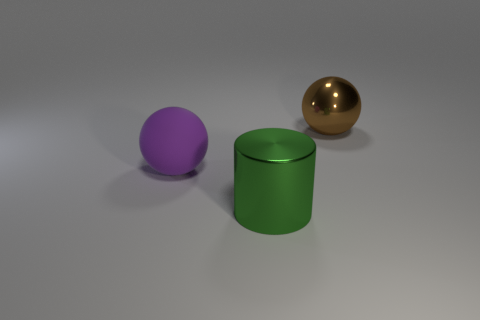What number of other things are the same shape as the purple thing?
Provide a succinct answer. 1. Does the brown metallic thing have the same shape as the big metal thing that is in front of the large shiny sphere?
Provide a short and direct response. No. There is a large brown metallic sphere; how many large metallic spheres are on the left side of it?
Make the answer very short. 0. Is there anything else that has the same material as the brown sphere?
Give a very brief answer. Yes. Does the big object that is on the left side of the green cylinder have the same shape as the green thing?
Provide a succinct answer. No. The shiny object that is left of the shiny sphere is what color?
Give a very brief answer. Green. What shape is the green thing that is the same material as the brown object?
Make the answer very short. Cylinder. Is there any other thing that is the same color as the cylinder?
Give a very brief answer. No. Is the number of large rubber spheres right of the purple rubber object greater than the number of big purple matte spheres that are behind the brown metal object?
Provide a short and direct response. No. What number of yellow shiny spheres have the same size as the brown thing?
Your answer should be very brief. 0. 